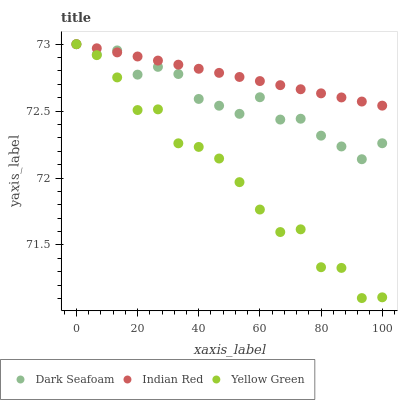Does Yellow Green have the minimum area under the curve?
Answer yes or no. Yes. Does Indian Red have the maximum area under the curve?
Answer yes or no. Yes. Does Indian Red have the minimum area under the curve?
Answer yes or no. No. Does Yellow Green have the maximum area under the curve?
Answer yes or no. No. Is Indian Red the smoothest?
Answer yes or no. Yes. Is Yellow Green the roughest?
Answer yes or no. Yes. Is Yellow Green the smoothest?
Answer yes or no. No. Is Indian Red the roughest?
Answer yes or no. No. Does Yellow Green have the lowest value?
Answer yes or no. Yes. Does Indian Red have the lowest value?
Answer yes or no. No. Does Indian Red have the highest value?
Answer yes or no. Yes. Does Yellow Green intersect Indian Red?
Answer yes or no. Yes. Is Yellow Green less than Indian Red?
Answer yes or no. No. Is Yellow Green greater than Indian Red?
Answer yes or no. No. 